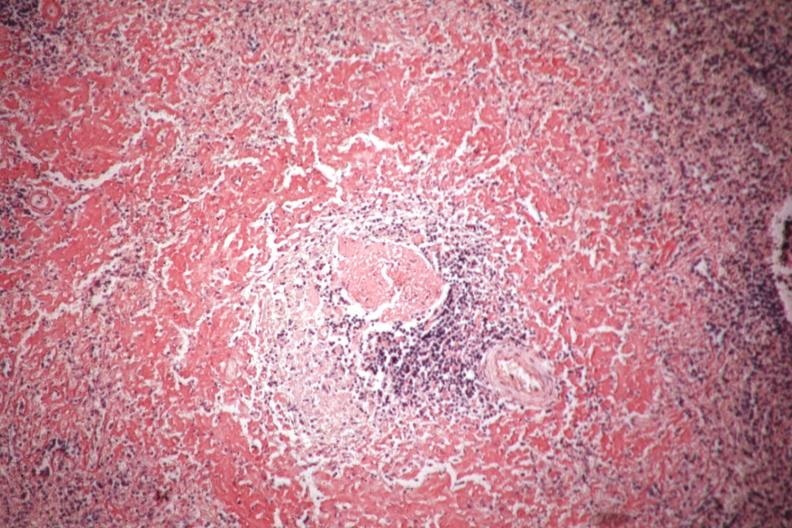what is present?
Answer the question using a single word or phrase. Hematologic 